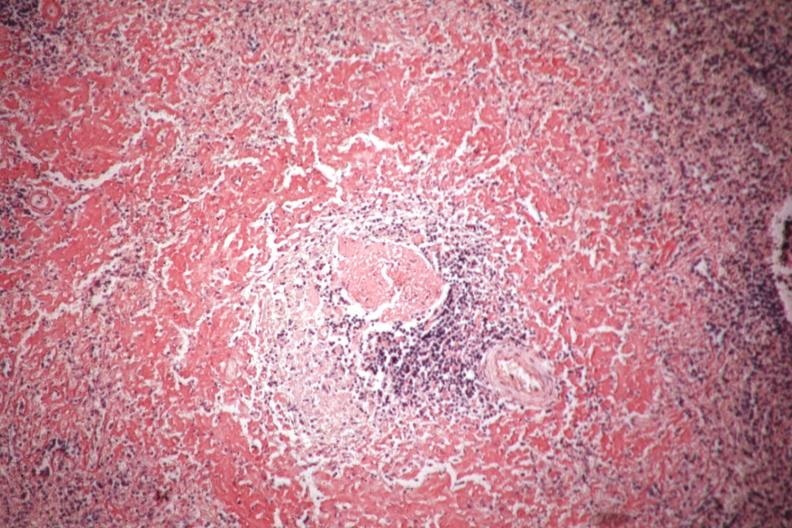what is present?
Answer the question using a single word or phrase. Hematologic 